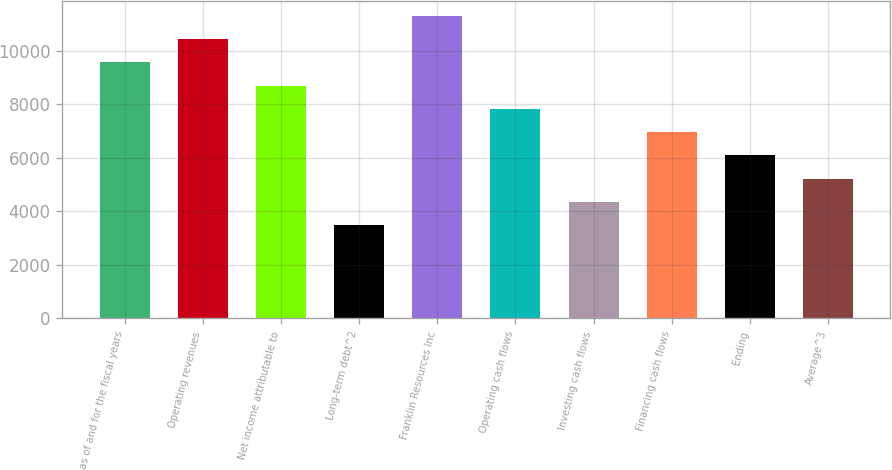Convert chart. <chart><loc_0><loc_0><loc_500><loc_500><bar_chart><fcel>as of and for the fiscal years<fcel>Operating revenues<fcel>Net income attributable to<fcel>Long-term debt^2<fcel>Franklin Resources Inc<fcel>Operating cash flows<fcel>Investing cash flows<fcel>Financing cash flows<fcel>Ending<fcel>Average^3<nl><fcel>9568.84<fcel>10438.7<fcel>8699<fcel>3479.96<fcel>11308.5<fcel>7829.16<fcel>4349.8<fcel>6959.32<fcel>6089.48<fcel>5219.64<nl></chart> 